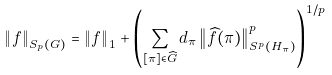<formula> <loc_0><loc_0><loc_500><loc_500>\left \| f \right \| _ { S _ { p } ( G ) } = \left \| f \right \| _ { 1 } + \left ( \sum _ { [ \pi ] \in \widehat { G } } d _ { \pi } \left \| \widehat { f } ( \pi ) \right \| _ { S ^ { p } ( H _ { \pi } ) } ^ { p } \right ) ^ { 1 / p }</formula> 